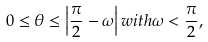Convert formula to latex. <formula><loc_0><loc_0><loc_500><loc_500>0 \leq \theta \leq \left | \frac { \pi } { 2 } - \omega \right | w i t h \omega < \frac { \pi } { 2 } ,</formula> 